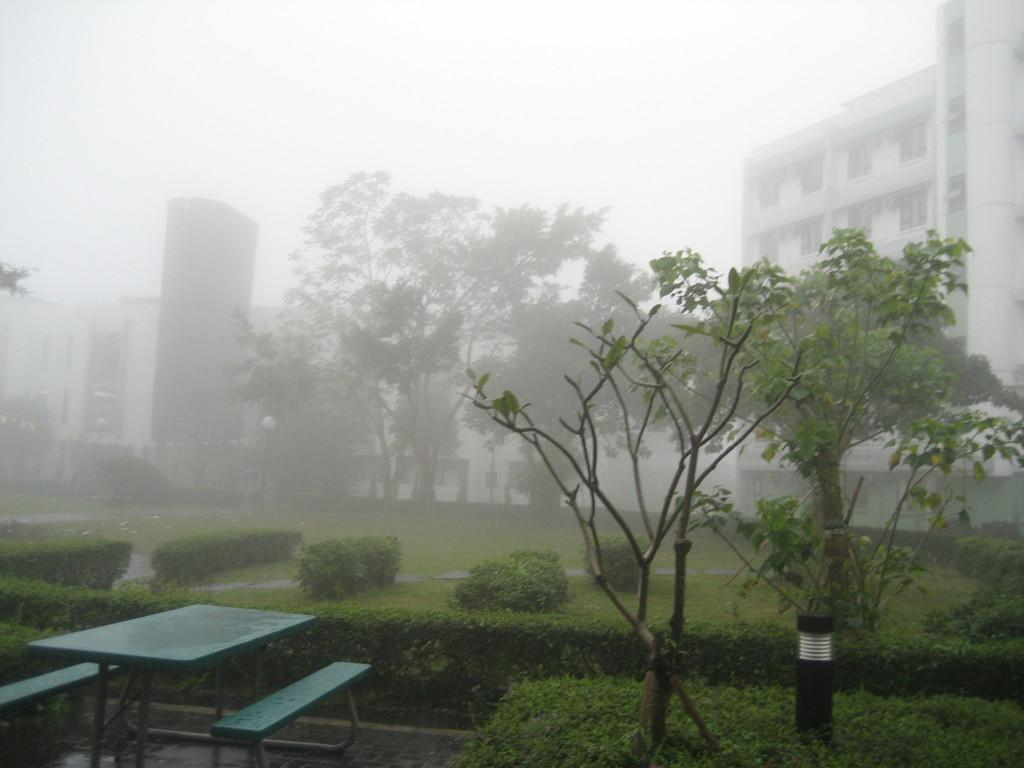What type of vegetation can be seen in the image? There are trees in the image. What color are the trees? The trees are green. How many benches are present in the image? There are two benches in the image. What color are the benches? The benches are green. What other object can be seen in the image? There is a table in the image. What color is the table? The table is green. What can be seen in the background of the image? There are buildings in the background of the image. What is visible in the sky in the image? The sky is visible in the image and appears white. What month is depicted in the image? The image does not depict a specific month; it only shows trees, benches, a table, buildings, and a white sky. What type of work is being done in the image? There is no indication of any work being done in the image; it is a scene of trees, benches, a table, buildings, and a white sky. 